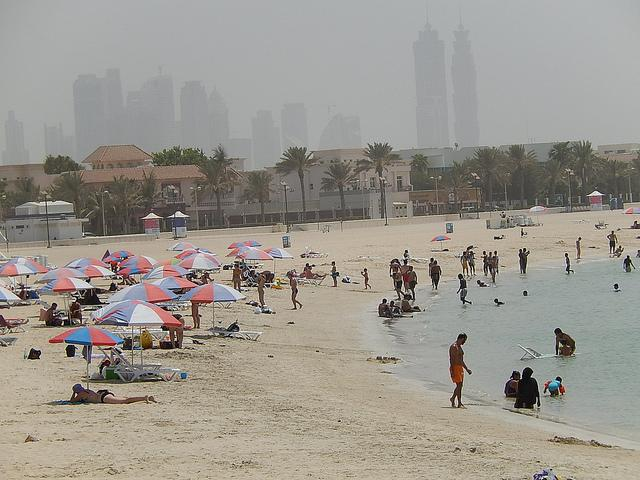Why are all the umbrellas there?

Choices:
A) keep dry
B) for sale
C) left there
D) sun protection sun protection 